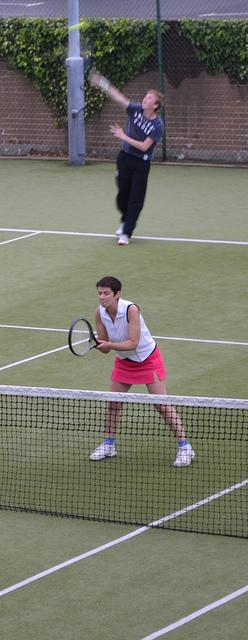What type of tennis are these two players playing? Please explain your reasoning. mixed doubles. Mixed doubles since one player is a woman. 